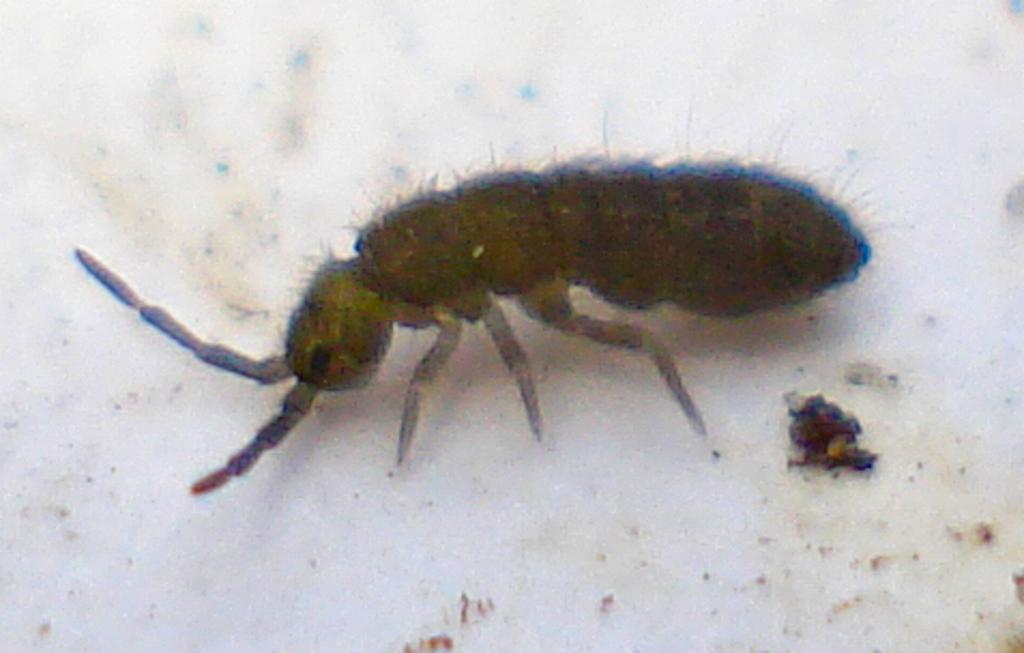What type of creature is in the image? There is an insect in the image. What colors can be seen on the insect? The insect has black and green coloring. What is the background or surface on which the insect is located? The insect is on a white surface. What type of pan is being used to sort the end in the image? There is no pan or end present in the image; it features an insect on a white surface. 